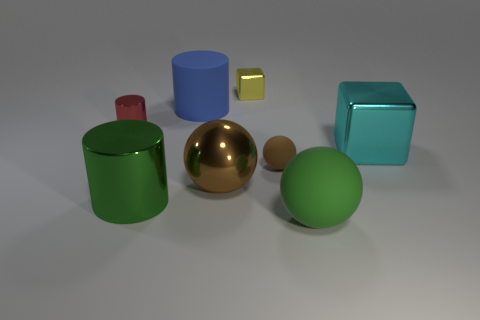There is a large ball that is the same color as the tiny sphere; what is it made of?
Make the answer very short. Metal. Do the small ball and the large matte cylinder have the same color?
Provide a short and direct response. No. What number of other things are there of the same material as the green ball
Provide a succinct answer. 2. What is the shape of the small metallic object that is on the left side of the big cylinder that is in front of the big cyan object?
Give a very brief answer. Cylinder. How big is the shiny thing that is behind the blue rubber object?
Ensure brevity in your answer.  Small. Are the small red thing and the cyan object made of the same material?
Provide a short and direct response. Yes. There is a big green thing that is made of the same material as the tiny block; what is its shape?
Offer a very short reply. Cylinder. Is there any other thing of the same color as the big shiny ball?
Your response must be concise. Yes. The metal cube behind the big cyan block is what color?
Provide a short and direct response. Yellow. Is the color of the tiny object that is on the left side of the small yellow block the same as the large metal cylinder?
Offer a terse response. No. 